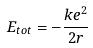<formula> <loc_0><loc_0><loc_500><loc_500>E _ { t o t } = - \frac { k e ^ { 2 } } { 2 r }</formula> 